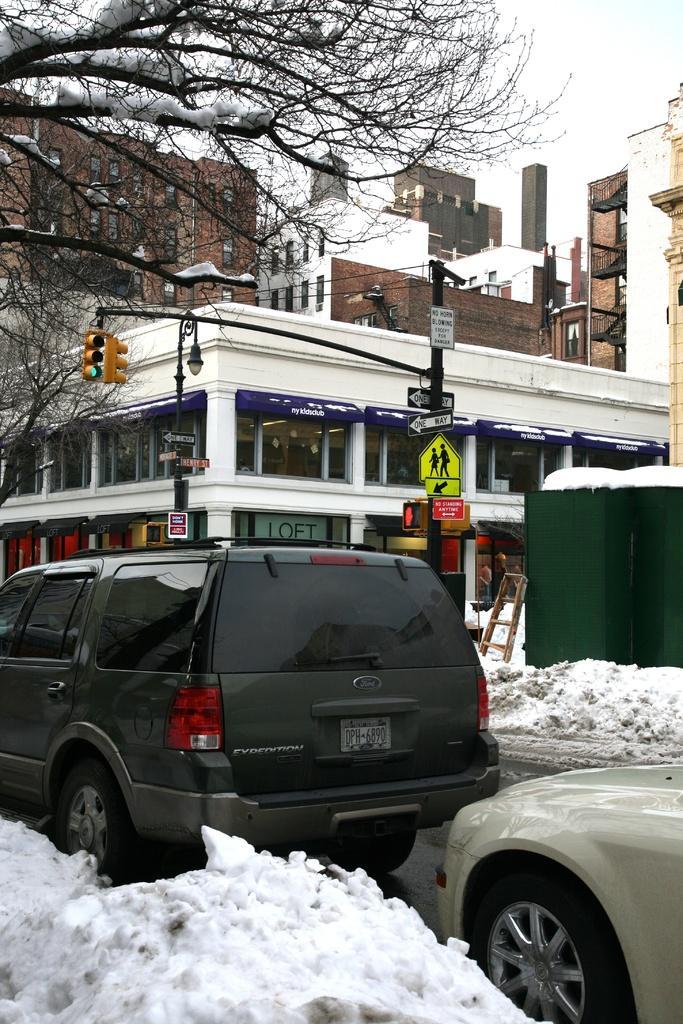Could you give a brief overview of what you see in this image? In this image I can see few vehicles on the road, in front the vehicle is in black color. Background I can see few buildings in white, brown and cream color, a traffic signal, a light pole, snow is in white color, few dried trees and the sky is in white color. 